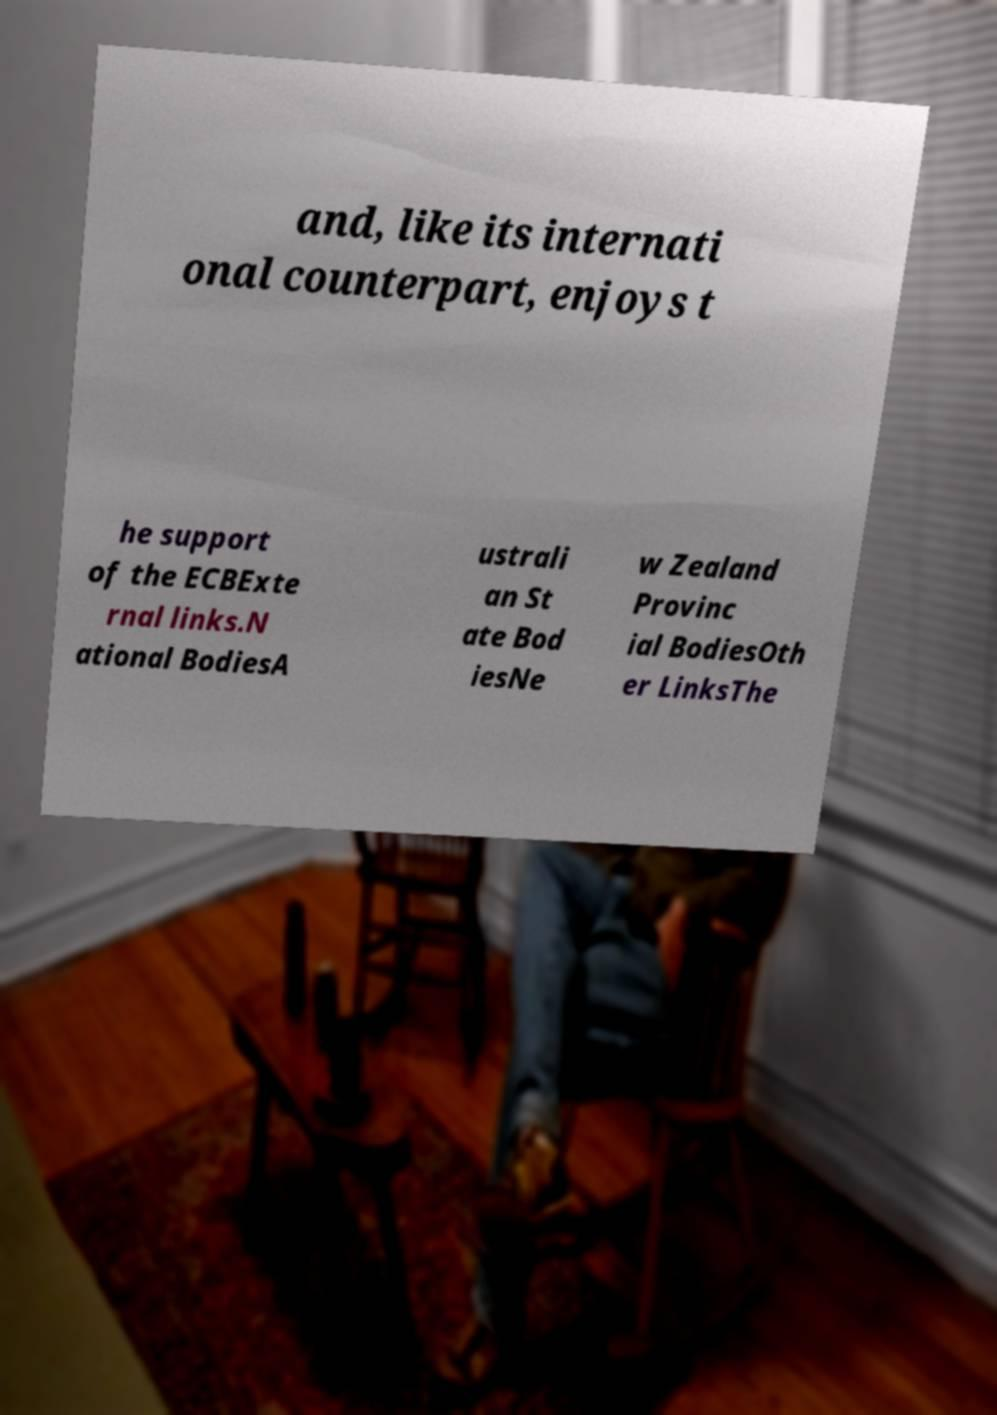Could you extract and type out the text from this image? and, like its internati onal counterpart, enjoys t he support of the ECBExte rnal links.N ational BodiesA ustrali an St ate Bod iesNe w Zealand Provinc ial BodiesOth er LinksThe 